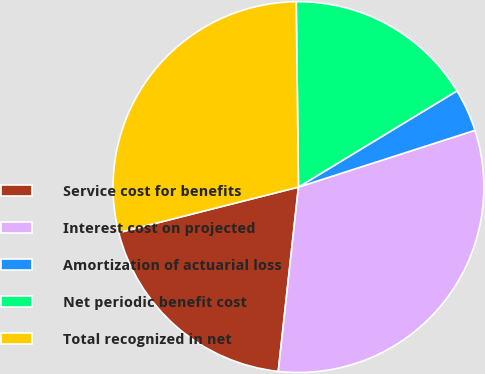Convert chart. <chart><loc_0><loc_0><loc_500><loc_500><pie_chart><fcel>Service cost for benefits<fcel>Interest cost on projected<fcel>Amortization of actuarial loss<fcel>Net periodic benefit cost<fcel>Total recognized in net<nl><fcel>19.31%<fcel>31.69%<fcel>3.73%<fcel>16.51%<fcel>28.76%<nl></chart> 